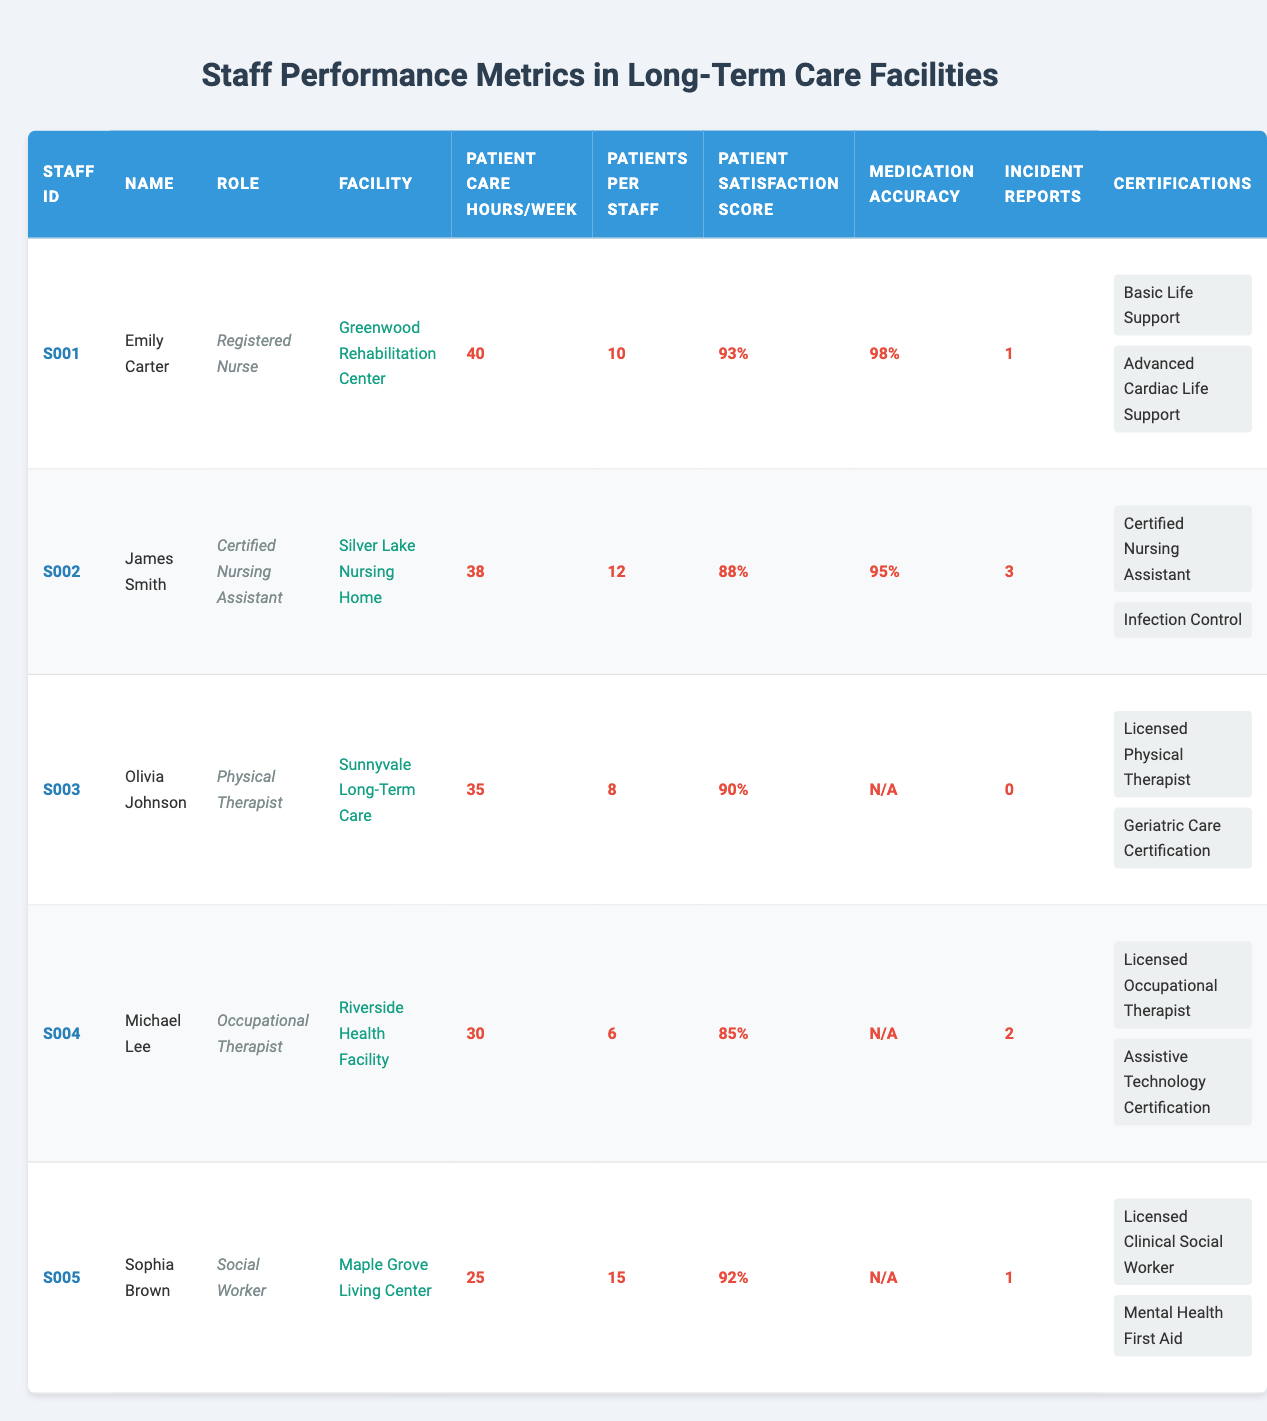What is the patient satisfaction score of Emily Carter? From the table, we can find Emily Carter's row and locate the patient satisfaction score listed, which is 93%.
Answer: 93% How many incident reports were filed by James Smith? By checking the table for James Smith, we see that the number of incident reports listed is 3.
Answer: 3 Who has the least patient care hours per week? Looking through the patient care hours for each staff member, Sophia Brown has the least at 25 hours per week.
Answer: Sophia Brown What is the average patient satisfaction score for all staff? To find the average, we sum the patient satisfaction scores: (93 + 88 + 90 + 85 + 92) = 448. Then we divide by the number of staff (5), giving us 448/5 = 89.6.
Answer: 89.6 Is there any staff member with a medication administration accuracy of 100%? Checking the medication administration accuracy, none of the staff members show a score of 100%; Emily Carter has the highest at 98%.
Answer: No Which staff member has the highest number of patients assigned to them? By reviewing the "Patients Per Staff" column, Sophia Brown has the highest at 15 patients.
Answer: Sophia Brown What is the total number of incident reports for all staff members combined? Summing the incident reports from the table gives: 1 (Emily) + 3 (James) + 0 (Olivia) + 2 (Michael) + 1 (Sophia) = 7.
Answer: 7 Does any staff member have a medication administration accuracy listed as 'N/A'? Reviewing the medication administration accuracy for all staff members shows that Olivia Johnson, Michael Lee, and Sophia Brown have 'N/A' listed.
Answer: Yes Which facility houses the staff member with the second highest patient care hours? Emily Carter has the highest at 40 hours, and James Smith follows with 38 hours. James works at Silver Lake Nursing Home.
Answer: Silver Lake Nursing Home If we consider the average patients per nurse/therapist/social worker, what is it? The total patients per staff is calculated as: (10 + 12 + 8 + 6 + 15)/5 = 51/5 = 10.2.
Answer: 10.2 